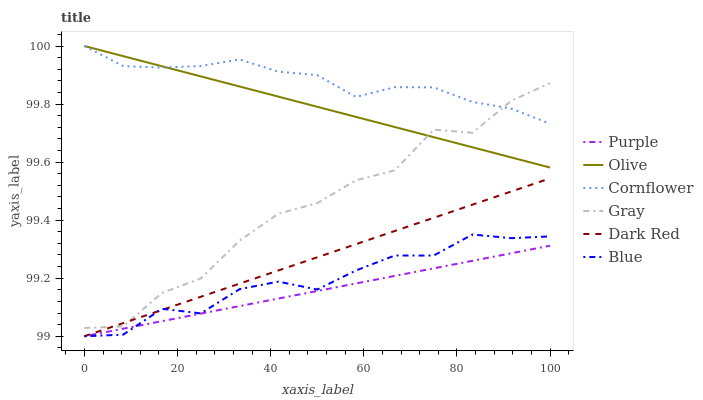Does Purple have the minimum area under the curve?
Answer yes or no. Yes. Does Cornflower have the maximum area under the curve?
Answer yes or no. Yes. Does Gray have the minimum area under the curve?
Answer yes or no. No. Does Gray have the maximum area under the curve?
Answer yes or no. No. Is Olive the smoothest?
Answer yes or no. Yes. Is Gray the roughest?
Answer yes or no. Yes. Is Cornflower the smoothest?
Answer yes or no. No. Is Cornflower the roughest?
Answer yes or no. No. Does Blue have the lowest value?
Answer yes or no. Yes. Does Gray have the lowest value?
Answer yes or no. No. Does Olive have the highest value?
Answer yes or no. Yes. Does Gray have the highest value?
Answer yes or no. No. Is Blue less than Olive?
Answer yes or no. Yes. Is Gray greater than Purple?
Answer yes or no. Yes. Does Blue intersect Dark Red?
Answer yes or no. Yes. Is Blue less than Dark Red?
Answer yes or no. No. Is Blue greater than Dark Red?
Answer yes or no. No. Does Blue intersect Olive?
Answer yes or no. No. 